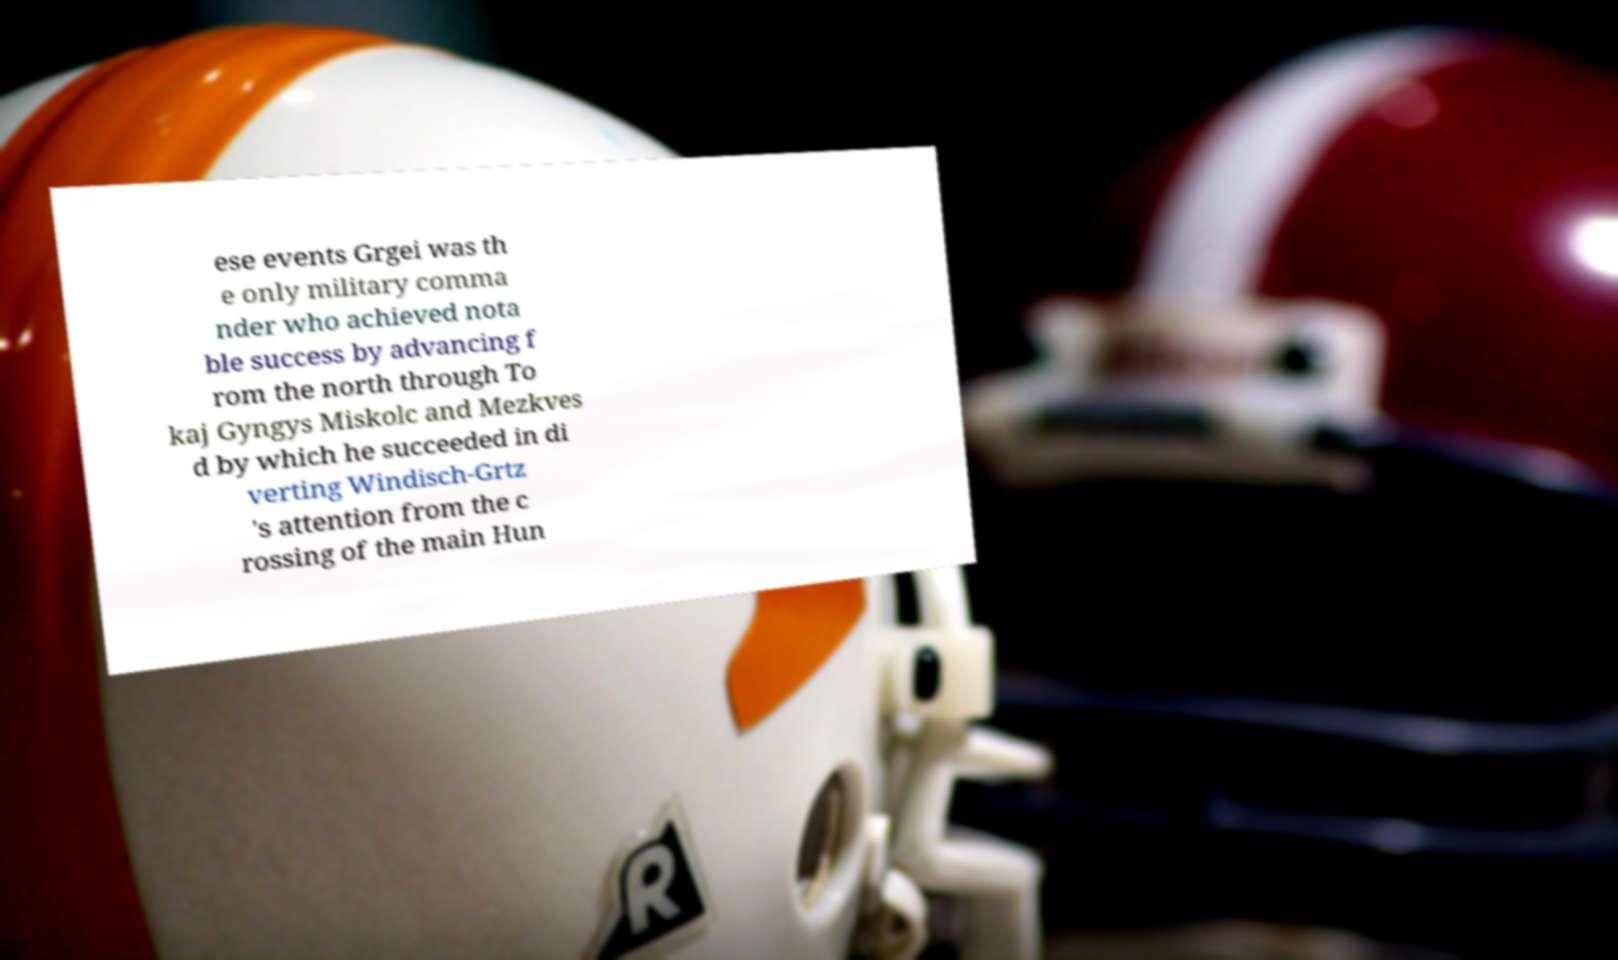There's text embedded in this image that I need extracted. Can you transcribe it verbatim? ese events Grgei was th e only military comma nder who achieved nota ble success by advancing f rom the north through To kaj Gyngys Miskolc and Mezkves d by which he succeeded in di verting Windisch-Grtz 's attention from the c rossing of the main Hun 